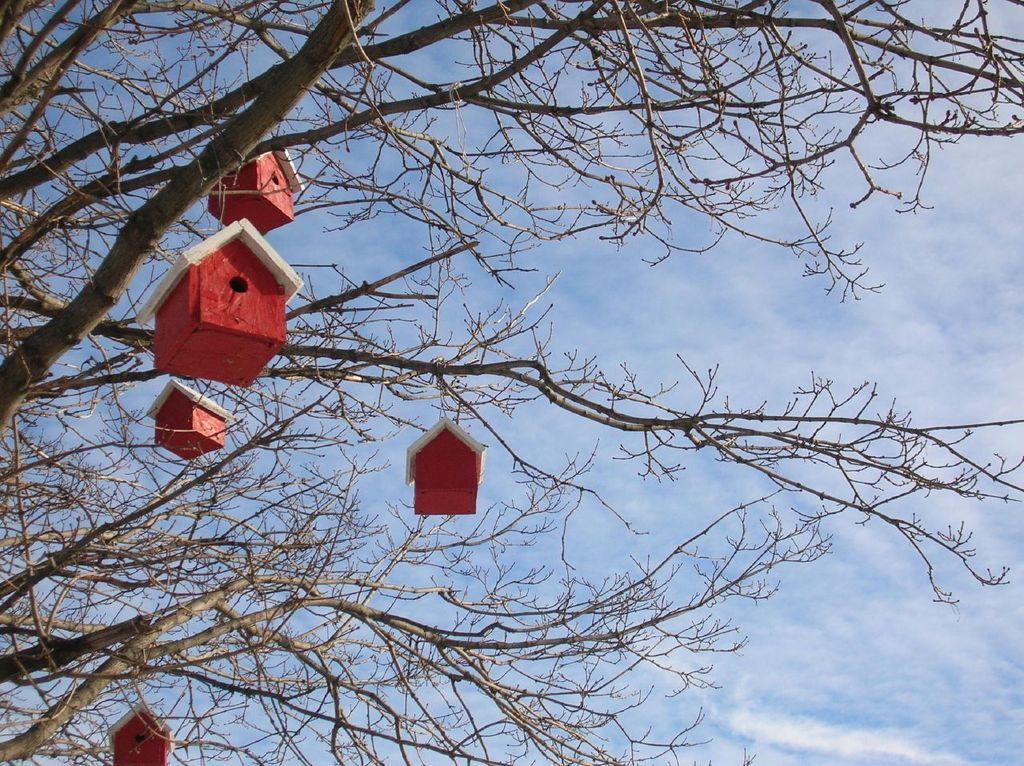Please provide a concise description of this image. In this image we can see house like structures hanged to the branch of a tree. In the background there is a sky and clouds. 